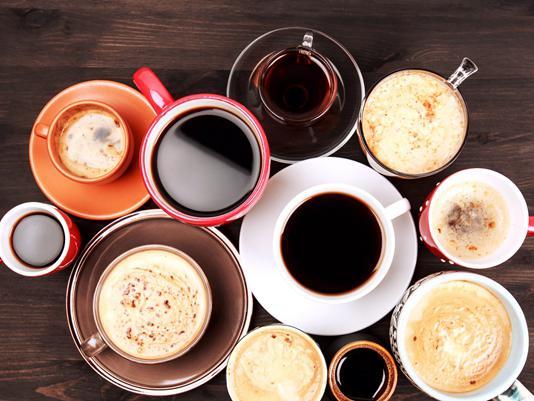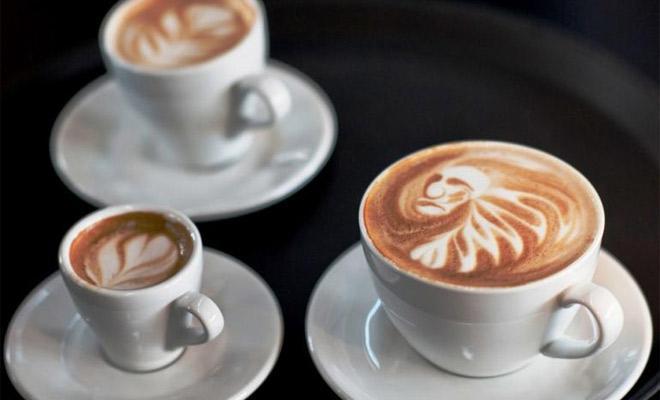The first image is the image on the left, the second image is the image on the right. Examine the images to the left and right. Is the description "All cups have patterns created by swirls of cream in a brown beverage showing at their tops." accurate? Answer yes or no. No. The first image is the image on the left, the second image is the image on the right. For the images displayed, is the sentence "All the coffees contain milk." factually correct? Answer yes or no. No. 